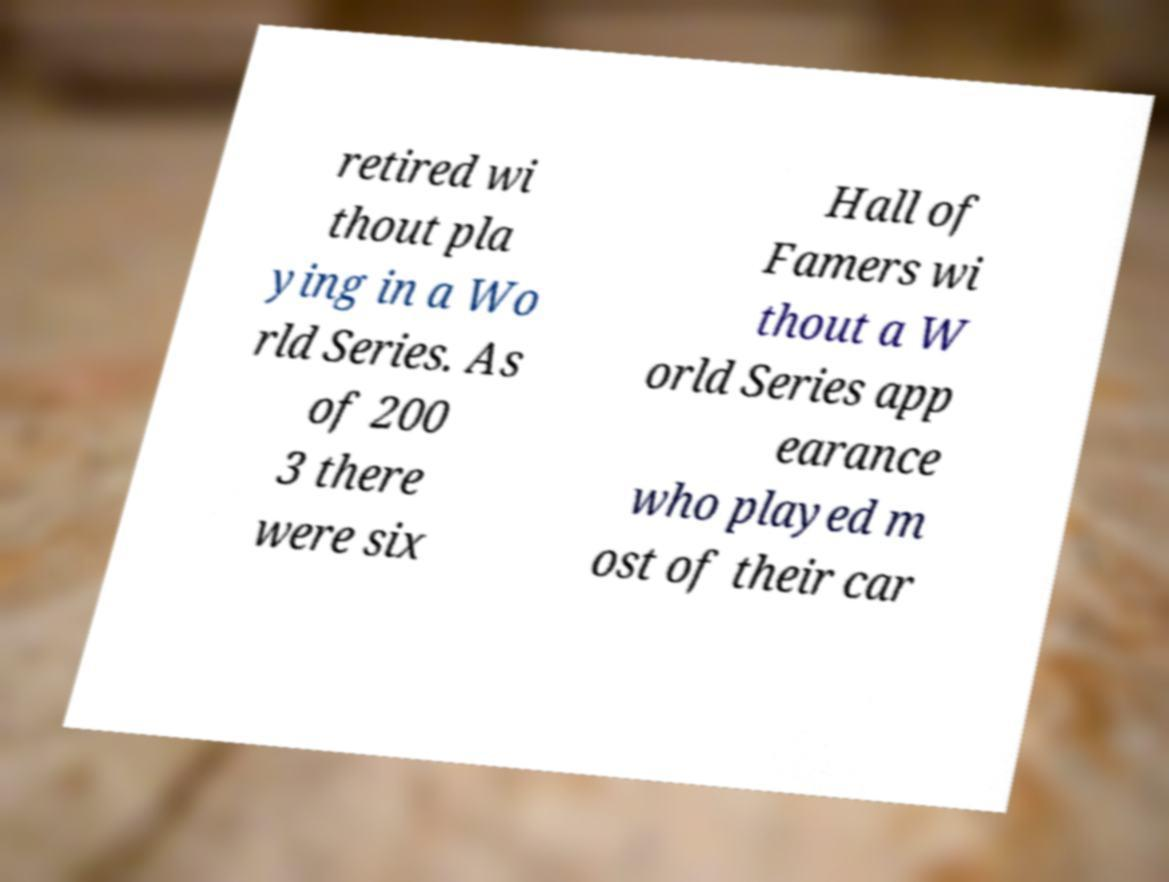I need the written content from this picture converted into text. Can you do that? retired wi thout pla ying in a Wo rld Series. As of 200 3 there were six Hall of Famers wi thout a W orld Series app earance who played m ost of their car 